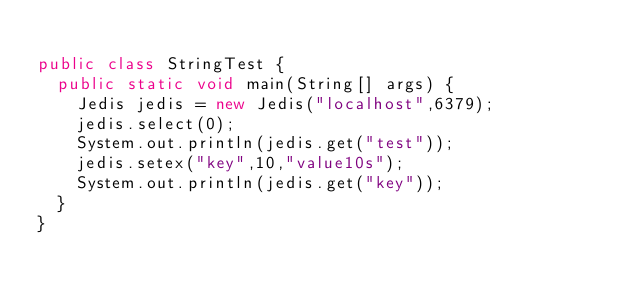Convert code to text. <code><loc_0><loc_0><loc_500><loc_500><_Java_>
public class StringTest {
	public static void main(String[] args) {
		Jedis jedis = new Jedis("localhost",6379);
		jedis.select(0);
		System.out.println(jedis.get("test"));
		jedis.setex("key",10,"value10s");
		System.out.println(jedis.get("key"));
	}
}
</code> 